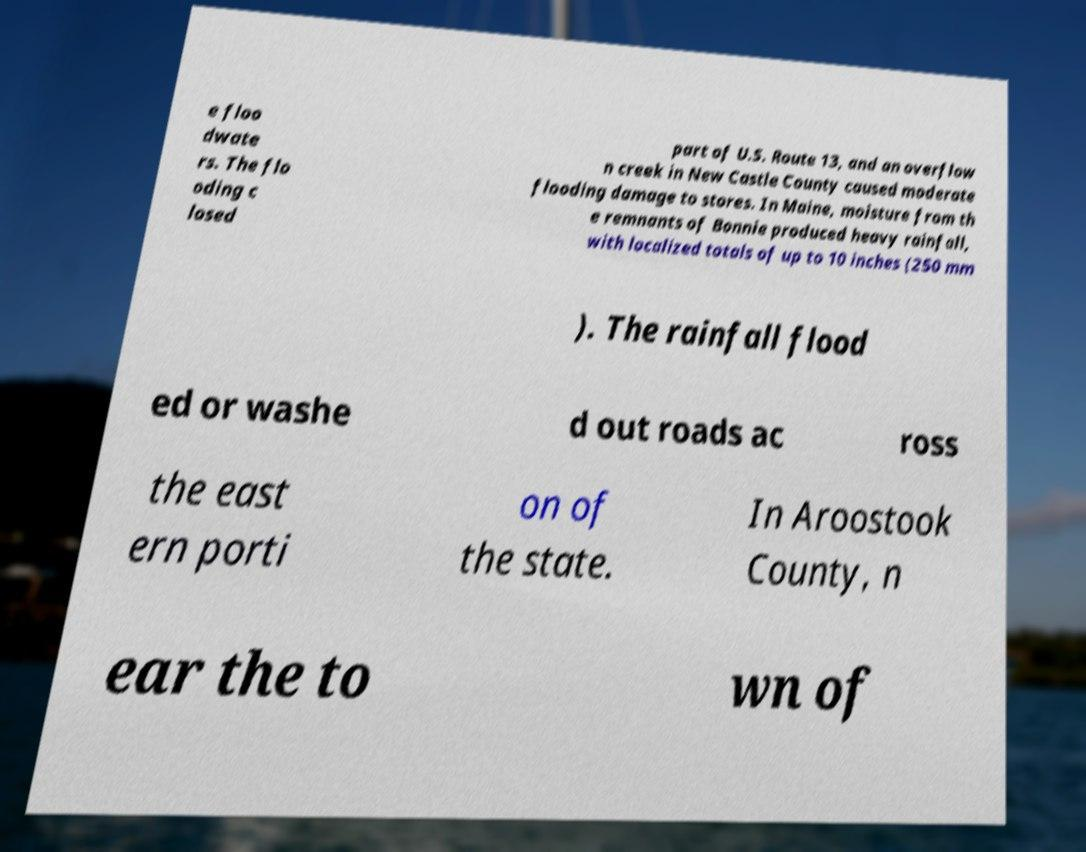Can you accurately transcribe the text from the provided image for me? e floo dwate rs. The flo oding c losed part of U.S. Route 13, and an overflow n creek in New Castle County caused moderate flooding damage to stores. In Maine, moisture from th e remnants of Bonnie produced heavy rainfall, with localized totals of up to 10 inches (250 mm ). The rainfall flood ed or washe d out roads ac ross the east ern porti on of the state. In Aroostook County, n ear the to wn of 